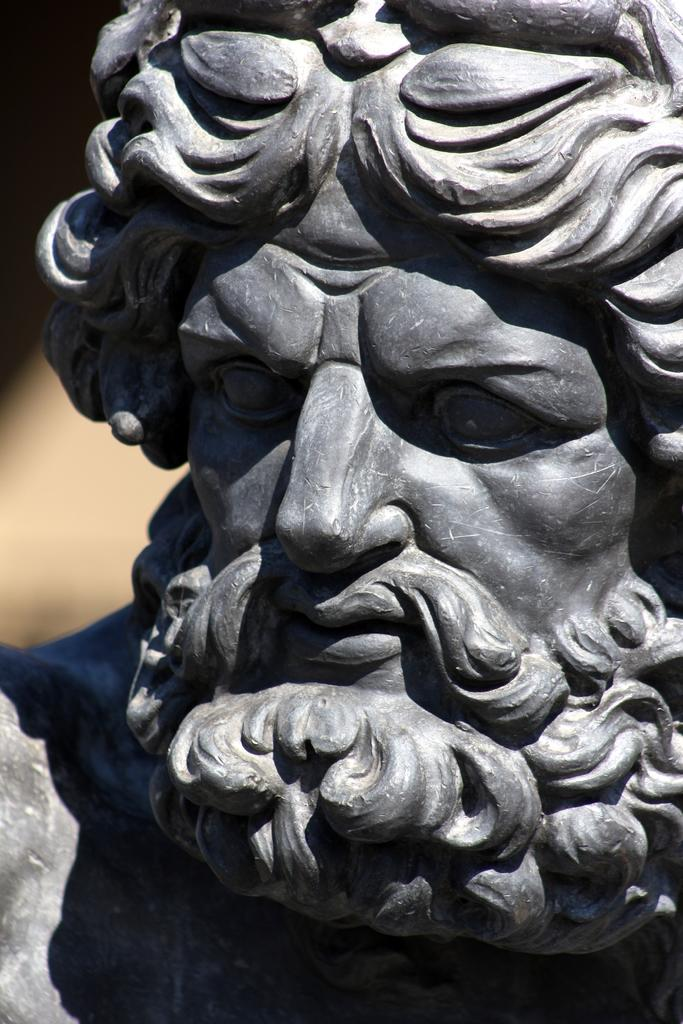What is the main subject of the image? There is a statue of a man in the image. What can be observed about the background of the image? The background of the image is dark. What type of haircut is the man in the image getting from the scissors? There are no scissors or any indication of a haircut in the image; it only features a statue of a man. 